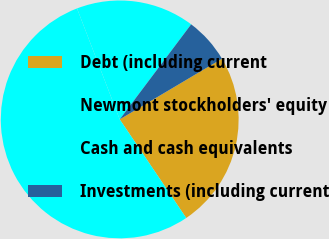Convert chart to OTSL. <chart><loc_0><loc_0><loc_500><loc_500><pie_chart><fcel>Debt (including current<fcel>Newmont stockholders' equity<fcel>Cash and cash equivalents<fcel>Investments (including current<nl><fcel>24.08%<fcel>53.6%<fcel>16.1%<fcel>6.22%<nl></chart> 